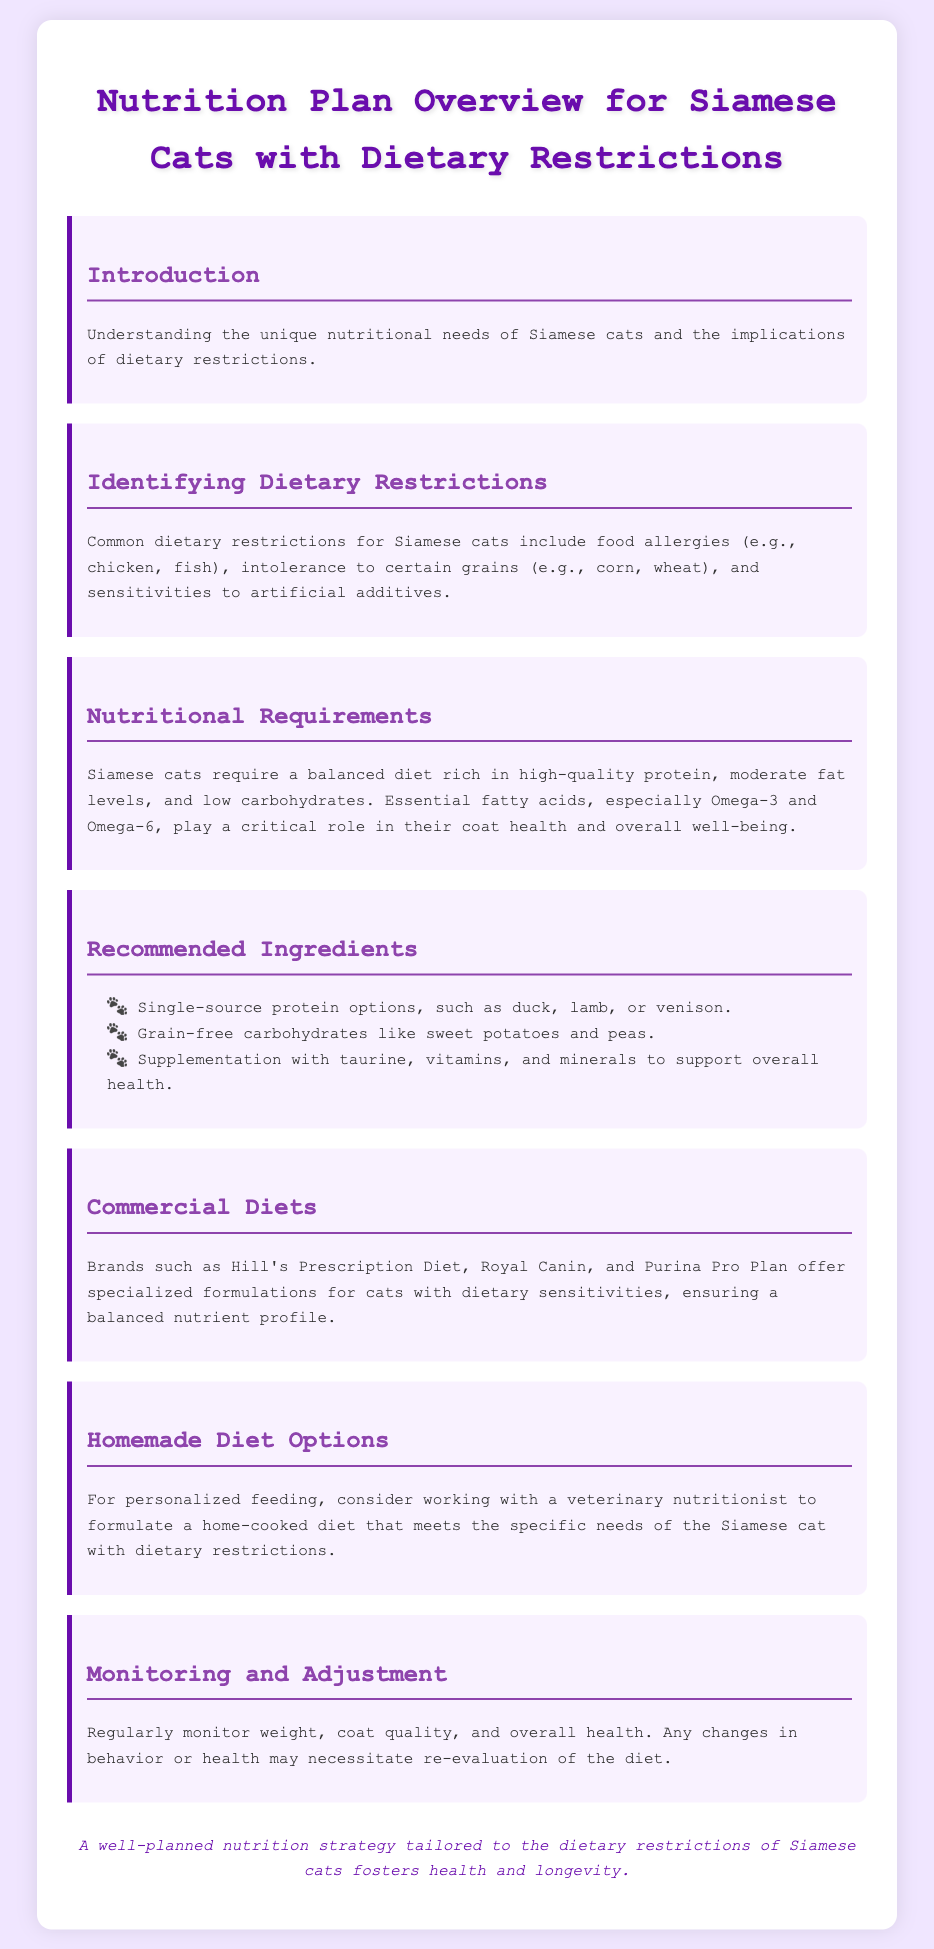What are common dietary restrictions for Siamese cats? The document lists food allergies, intolerance to certain grains, and sensitivities to artificial additives as common dietary restrictions.
Answer: Food allergies, intolerance to certain grains, sensitivities to artificial additives What is the importance of Omega-3 and Omega-6 fatty acids? The document states that these essential fatty acids play a critical role in coat health and overall well-being for Siamese cats.
Answer: Coat health and overall well-being Name one recommended single-source protein option. The document provides examples of single-source protein options for Siamese cats; one example is mentioned.
Answer: Duck What type of carbohydrates are recommended for Siamese cats? The document describes recommended carbohydrates as grain-free options, specifically naming two types.
Answer: Grain-free carbohydrates like sweet potatoes and peas Which brands offer specialized formulations for cats with dietary sensitivities? The document mentions brands that provide specialized diets for cats; three brands are specifically identified.
Answer: Hill's Prescription Diet, Royal Canin, Purina Pro Plan What should be done if there are changes in behavior or health? According to the document, changes in behavior or health may necessitate a specific action relating to the diet.
Answer: Re-evaluation of the diet What is suggested for personalized feeding options? The document recommends working with a specific type of professional to formulate a home-cooked diet.
Answer: Veterinary nutritionist How should Siamese cats' weight and health be monitored? The document emphasizes the importance of monitoring specific aspects to evaluate health effectively.
Answer: Regularly monitor weight, coat quality, and overall health 